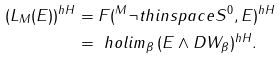<formula> <loc_0><loc_0><loc_500><loc_500>( L _ { M } ( E ) ) ^ { h H } & = F ( ^ { M } \neg t h i n s p a c e S ^ { 0 } , E ) ^ { h H } \\ & = \ h o l i m _ { \beta } \, ( E \wedge D W _ { \beta } ) ^ { h H } .</formula> 